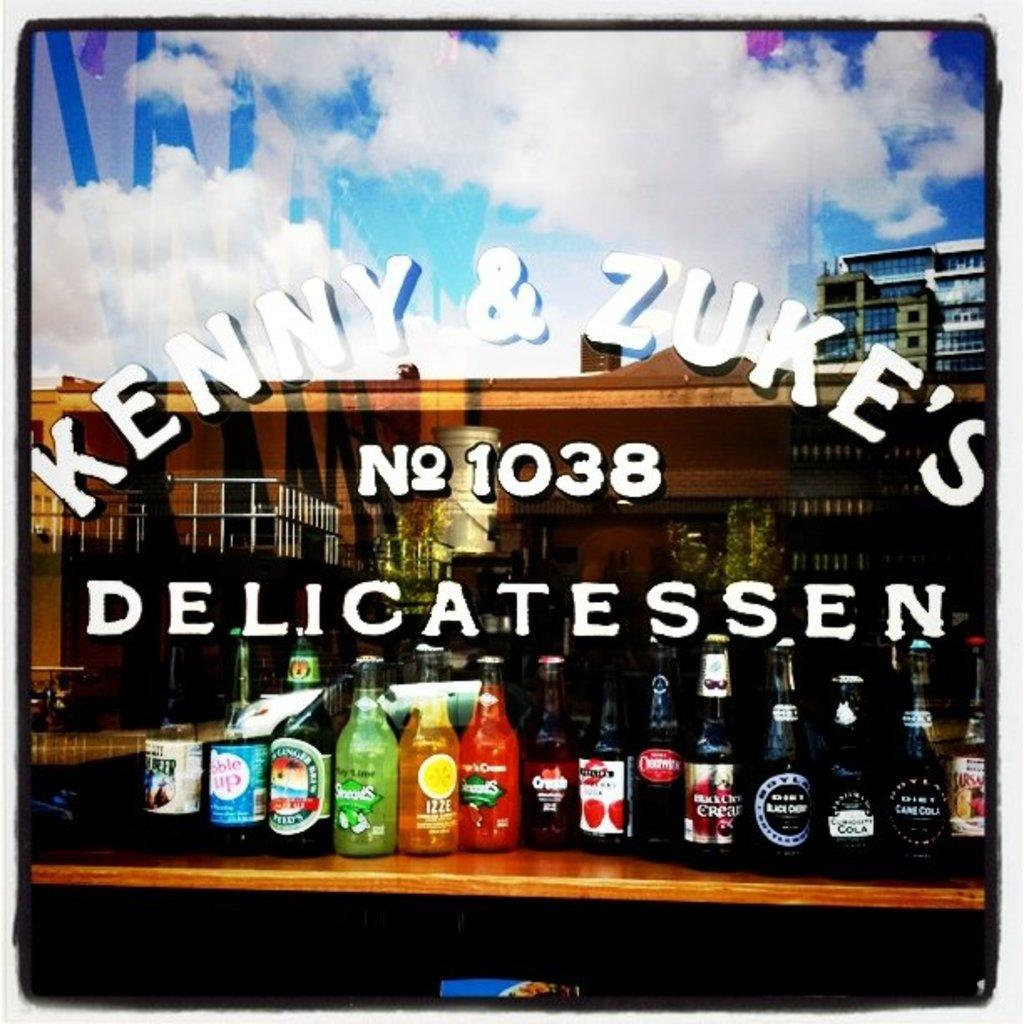What objects are on the table in the image? There are bottles on the table in the image. What can be found on the bottles? The bottles have labels on them. What type of pin is holding the train to the wall in the image? There is no pin or train present in the image; it only features bottles with labels on the table. 